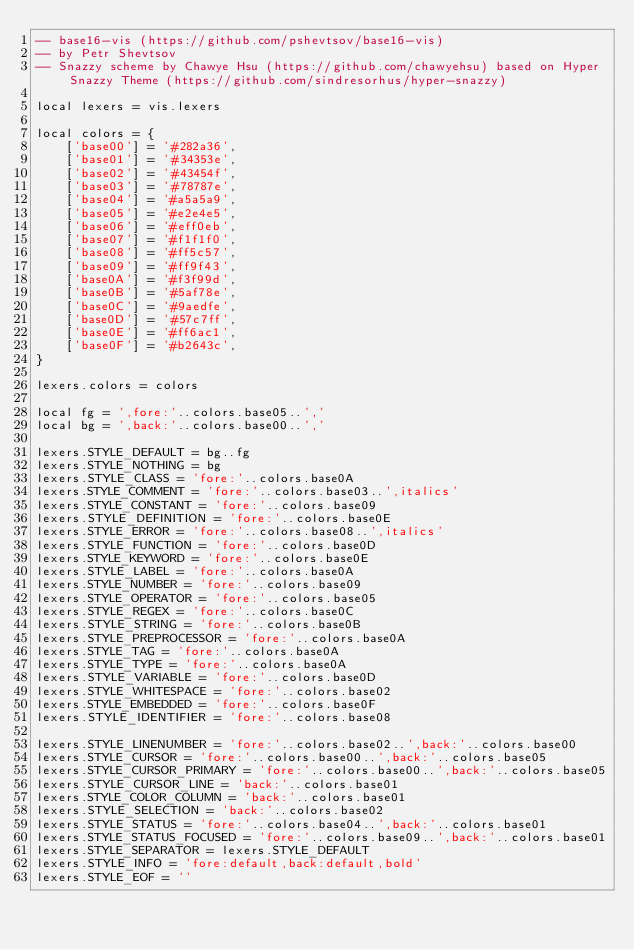Convert code to text. <code><loc_0><loc_0><loc_500><loc_500><_Lua_>-- base16-vis (https://github.com/pshevtsov/base16-vis)
-- by Petr Shevtsov
-- Snazzy scheme by Chawye Hsu (https://github.com/chawyehsu) based on Hyper Snazzy Theme (https://github.com/sindresorhus/hyper-snazzy)

local lexers = vis.lexers

local colors = {
	['base00'] = '#282a36',
	['base01'] = '#34353e',
	['base02'] = '#43454f',
	['base03'] = '#78787e',
	['base04'] = '#a5a5a9',
	['base05'] = '#e2e4e5',
	['base06'] = '#eff0eb',
	['base07'] = '#f1f1f0',
	['base08'] = '#ff5c57',
	['base09'] = '#ff9f43',
	['base0A'] = '#f3f99d',
	['base0B'] = '#5af78e',
	['base0C'] = '#9aedfe',
	['base0D'] = '#57c7ff',
	['base0E'] = '#ff6ac1',
	['base0F'] = '#b2643c',
}

lexers.colors = colors

local fg = ',fore:'..colors.base05..','
local bg = ',back:'..colors.base00..','

lexers.STYLE_DEFAULT = bg..fg
lexers.STYLE_NOTHING = bg
lexers.STYLE_CLASS = 'fore:'..colors.base0A
lexers.STYLE_COMMENT = 'fore:'..colors.base03..',italics'
lexers.STYLE_CONSTANT = 'fore:'..colors.base09
lexers.STYLE_DEFINITION = 'fore:'..colors.base0E
lexers.STYLE_ERROR = 'fore:'..colors.base08..',italics'
lexers.STYLE_FUNCTION = 'fore:'..colors.base0D
lexers.STYLE_KEYWORD = 'fore:'..colors.base0E
lexers.STYLE_LABEL = 'fore:'..colors.base0A
lexers.STYLE_NUMBER = 'fore:'..colors.base09
lexers.STYLE_OPERATOR = 'fore:'..colors.base05
lexers.STYLE_REGEX = 'fore:'..colors.base0C
lexers.STYLE_STRING = 'fore:'..colors.base0B
lexers.STYLE_PREPROCESSOR = 'fore:'..colors.base0A
lexers.STYLE_TAG = 'fore:'..colors.base0A
lexers.STYLE_TYPE = 'fore:'..colors.base0A
lexers.STYLE_VARIABLE = 'fore:'..colors.base0D
lexers.STYLE_WHITESPACE = 'fore:'..colors.base02
lexers.STYLE_EMBEDDED = 'fore:'..colors.base0F
lexers.STYLE_IDENTIFIER = 'fore:'..colors.base08

lexers.STYLE_LINENUMBER = 'fore:'..colors.base02..',back:'..colors.base00
lexers.STYLE_CURSOR = 'fore:'..colors.base00..',back:'..colors.base05
lexers.STYLE_CURSOR_PRIMARY = 'fore:'..colors.base00..',back:'..colors.base05
lexers.STYLE_CURSOR_LINE = 'back:'..colors.base01
lexers.STYLE_COLOR_COLUMN = 'back:'..colors.base01
lexers.STYLE_SELECTION = 'back:'..colors.base02
lexers.STYLE_STATUS = 'fore:'..colors.base04..',back:'..colors.base01
lexers.STYLE_STATUS_FOCUSED = 'fore:'..colors.base09..',back:'..colors.base01
lexers.STYLE_SEPARATOR = lexers.STYLE_DEFAULT
lexers.STYLE_INFO = 'fore:default,back:default,bold'
lexers.STYLE_EOF = ''
</code> 